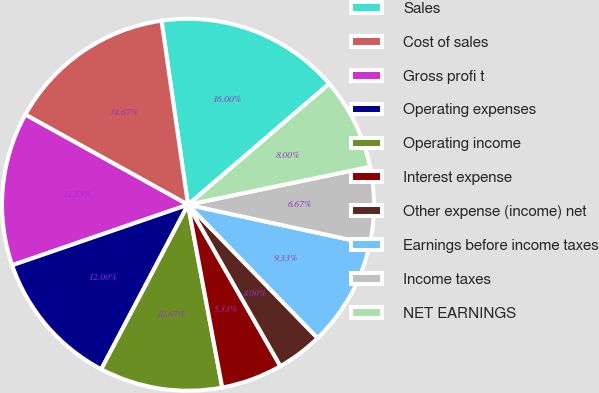Convert chart to OTSL. <chart><loc_0><loc_0><loc_500><loc_500><pie_chart><fcel>Sales<fcel>Cost of sales<fcel>Gross profi t<fcel>Operating expenses<fcel>Operating income<fcel>Interest expense<fcel>Other expense (income) net<fcel>Earnings before income taxes<fcel>Income taxes<fcel>NET EARNINGS<nl><fcel>16.0%<fcel>14.67%<fcel>13.33%<fcel>12.0%<fcel>10.67%<fcel>5.33%<fcel>4.0%<fcel>9.33%<fcel>6.67%<fcel>8.0%<nl></chart> 